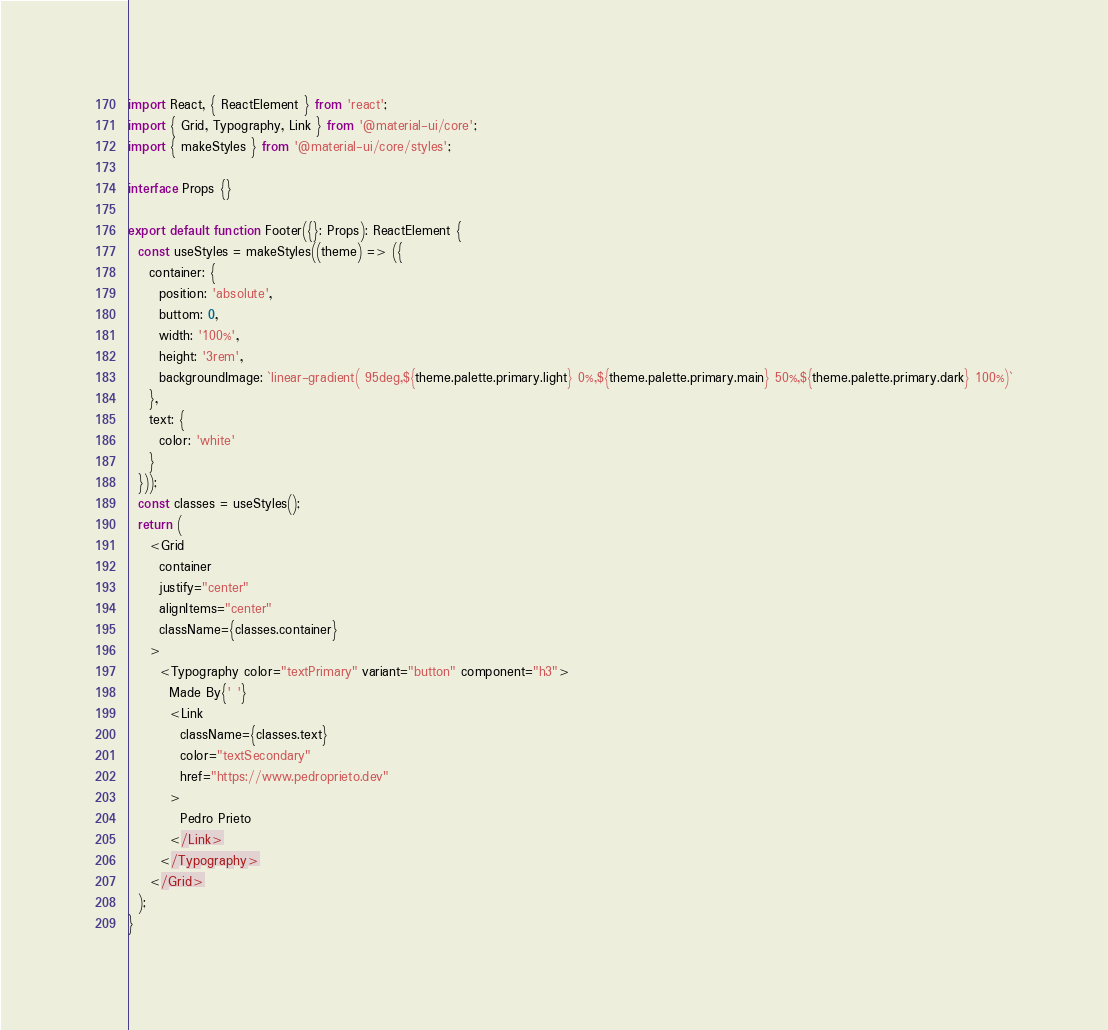<code> <loc_0><loc_0><loc_500><loc_500><_TypeScript_>import React, { ReactElement } from 'react';
import { Grid, Typography, Link } from '@material-ui/core';
import { makeStyles } from '@material-ui/core/styles';

interface Props {}

export default function Footer({}: Props): ReactElement {
  const useStyles = makeStyles((theme) => ({
    container: {
      position: 'absolute',
      buttom: 0,
      width: '100%',
      height: '3rem',
      backgroundImage: `linear-gradient( 95deg,${theme.palette.primary.light} 0%,${theme.palette.primary.main} 50%,${theme.palette.primary.dark} 100%)`
    },
    text: {
      color: 'white'
    }
  }));
  const classes = useStyles();
  return (
    <Grid
      container
      justify="center"
      alignItems="center"
      className={classes.container}
    >
      <Typography color="textPrimary" variant="button" component="h3">
        Made By{' '}
        <Link
          className={classes.text}
          color="textSecondary"
          href="https://www.pedroprieto.dev"
        >
          Pedro Prieto
        </Link>
      </Typography>
    </Grid>
  );
}
</code> 